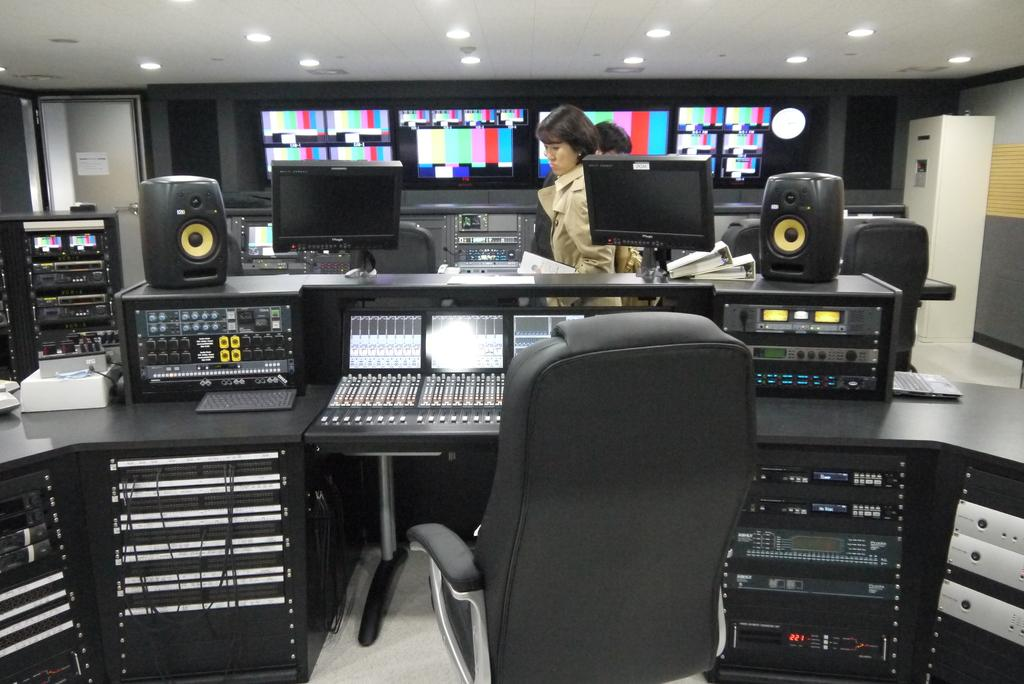What type of store is depicted in the image? The image depicts an electronics store. What type of furniture is present in the store? There is a chair in the store. What type of audio equipment is present in the store? Speakers are present in the store. What type of visual equipment is present in the store? Display screens are visible in the store. What type of lighting is present in the store? Electric lights are in the store, and lights are attached to the roof of the store. What type of products can be found in the store? Electric equipment is present in the store. How can customers enter and exit the store? There are doors in the store. What type of pets are allowed in the electronics store? There is no mention of pets in the image or the provided facts, so it cannot be determined if pets are allowed in the store. 